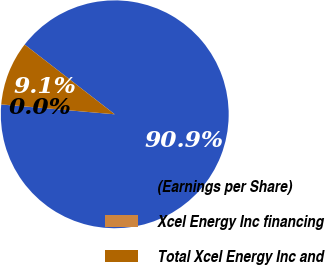Convert chart. <chart><loc_0><loc_0><loc_500><loc_500><pie_chart><fcel>(Earnings per Share)<fcel>Xcel Energy Inc financing<fcel>Total Xcel Energy Inc and<nl><fcel>90.9%<fcel>0.01%<fcel>9.1%<nl></chart> 